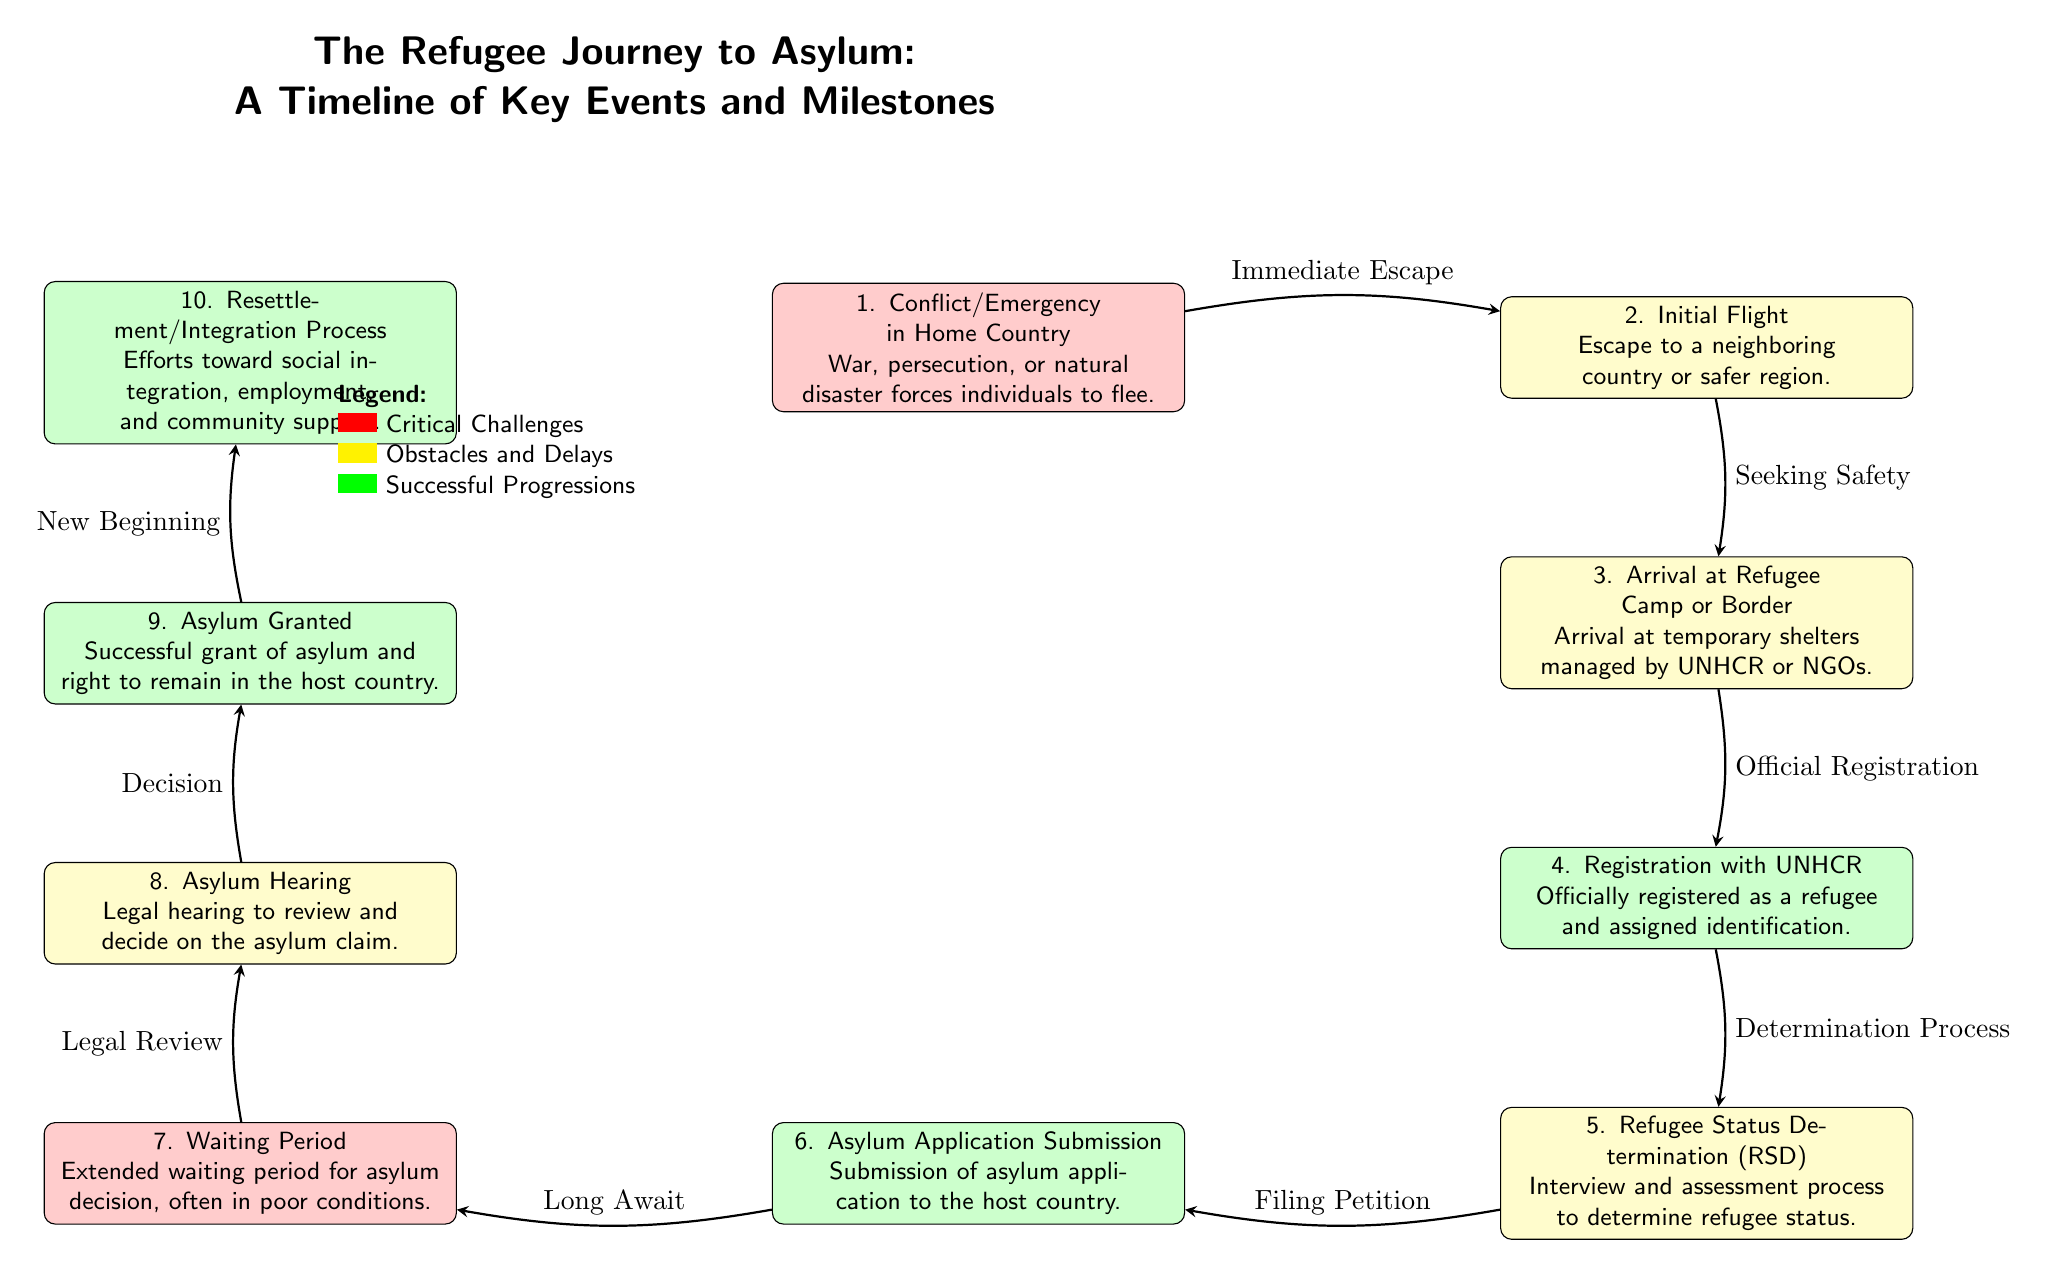What is the first event in the refugee journey to asylum? The first event is indicated at the top of the diagram and is labeled '1. Conflict/Emergency in Home Country,' which describes situations such as war, persecution, or natural disaster that force individuals to flee.
Answer: Conflict/Emergency in Home Country How many total events are shown in the timeline? By counting the events listed in the diagram, there are ten distinct events from '1. Conflict/Emergency in Home Country' to '10. Resettlement/Integration Process.'
Answer: 10 What type of event is 'Registration with UNHCR'? The node for 'Registration with UNHCR' is colored green, which according to the legend indicates it as a successful progression in the asylum journey.
Answer: Successful Progression What event comes immediately after 'Asylum Hearing'? Looking at the arrows between events, the next event after 'Asylum Hearing' is 'Asylum Granted,' which shows progression in the asylum process.
Answer: Asylum Granted Which event indicates a delay during the asylum process? Examining the diagram, 'Waiting Period' is marked with a red background and represents a critical challenge faced during the asylum process and implies a delay in receiving decisions.
Answer: Waiting Period What is the relationship between 'Asylum Application Submission' and 'Asylum Hearing'? The diagram connects these two events with an edge labeled 'Long Await,' indicating that there is a waiting period that links the submission of the asylum application to the hearing process.
Answer: Long Await What milestone indicates a new beginning for the refugee? The final milestone, 'Resettlement/Integration Process,' signifies a new beginning for the refugee, as it focuses on efforts toward social integration and support in the host country.
Answer: Resettlement/Integration Process Which two events are categorized as obstacles and delays? The events 'Waiting Period' and 'Refugee Status Determination (RSD)' are both colored yellow, indicating they are classified as obstacles and delays faced during the asylum process.
Answer: Waiting Period, Refugee Status Determination (RSD) What progresses the journey from 'Registration with UNHCR' to 'Refugee Status Determination (RSD)'? The edge between these two nodes is labeled 'Determination Process,' which denotes the progression that occurs after registration and leads to the status determination assessment.
Answer: Determination Process 